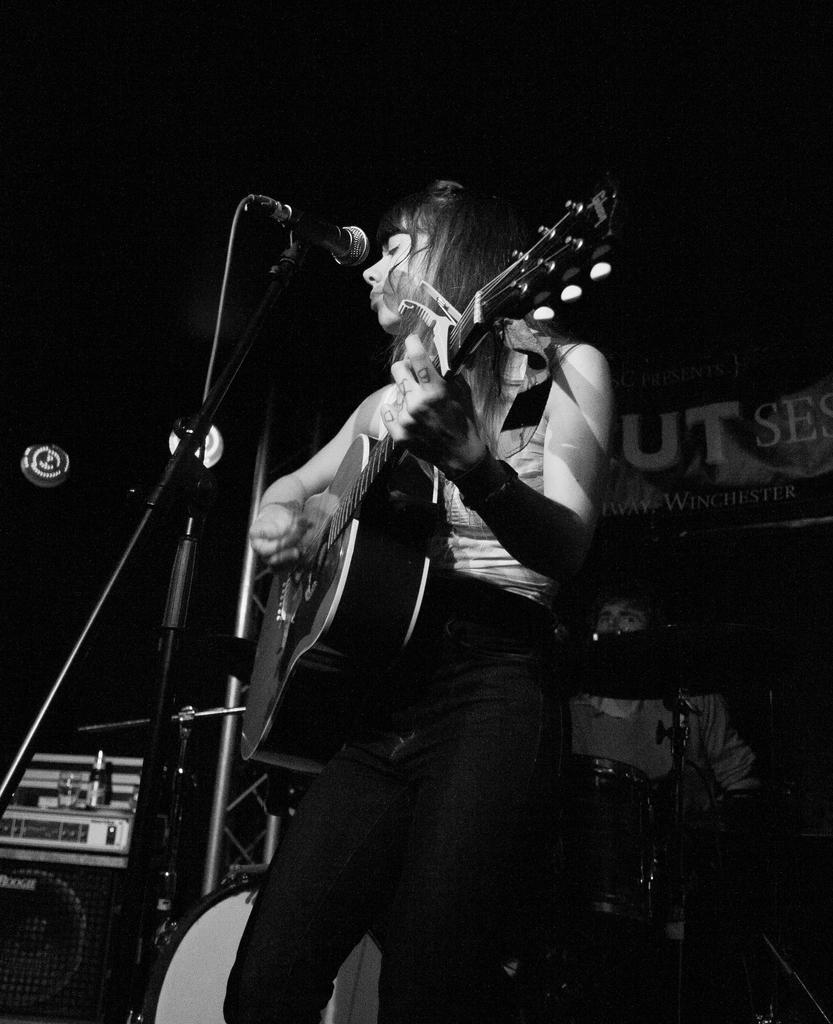What is the woman in the image doing? The woman is playing a guitar in the image. What object is near the woman that is used for amplifying sound? There is a microphone in the image. Can you describe the people visible in the background? There are people visible in the background, but their specific actions or features are not mentioned in the provided facts. What type of objects can be seen in the background related to music? There are musical instruments in the background. What type of spade is the woman using to dig in the image? There is no spade present in the image; the woman is playing a guitar. 